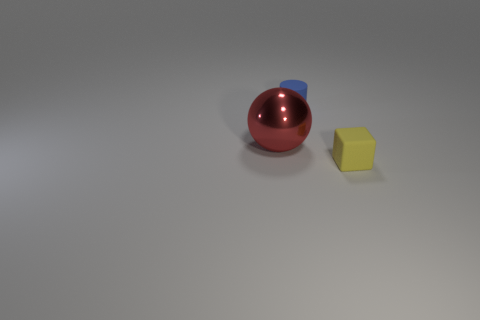Add 2 yellow cubes. How many objects exist? 5 Subtract all spheres. How many objects are left? 2 Add 3 matte blocks. How many matte blocks exist? 4 Subtract 0 gray cylinders. How many objects are left? 3 Subtract all large red metal balls. Subtract all cyan spheres. How many objects are left? 2 Add 3 big metallic things. How many big metallic things are left? 4 